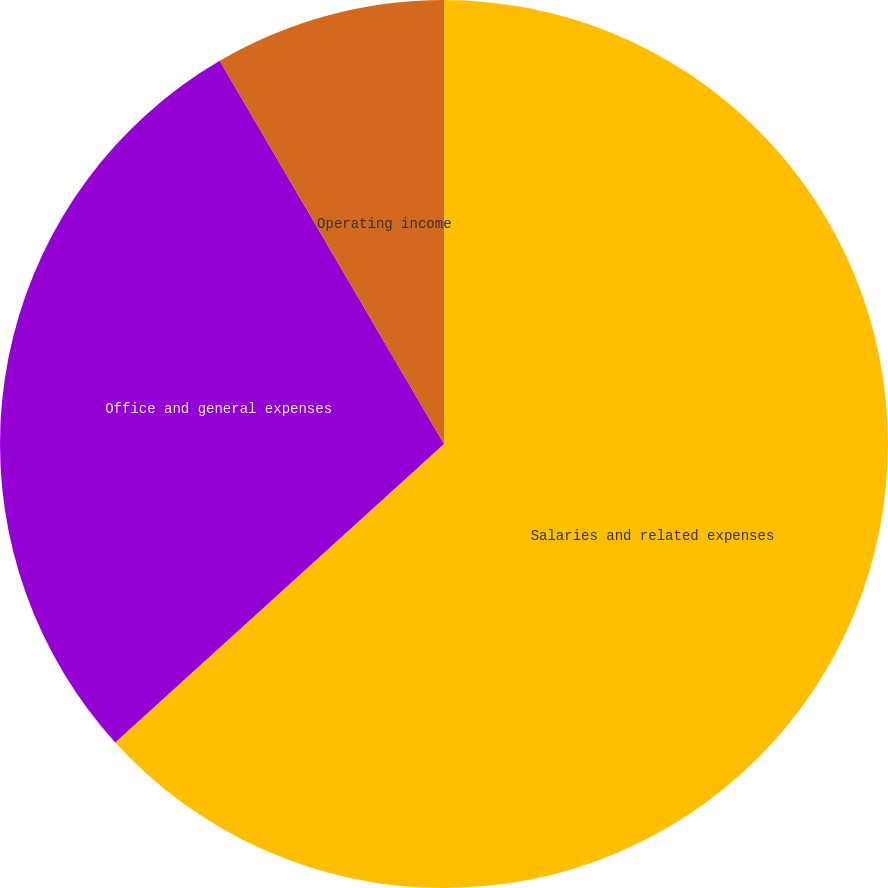Convert chart. <chart><loc_0><loc_0><loc_500><loc_500><pie_chart><fcel>Salaries and related expenses<fcel>Office and general expenses<fcel>Operating income<nl><fcel>63.27%<fcel>28.3%<fcel>8.43%<nl></chart> 